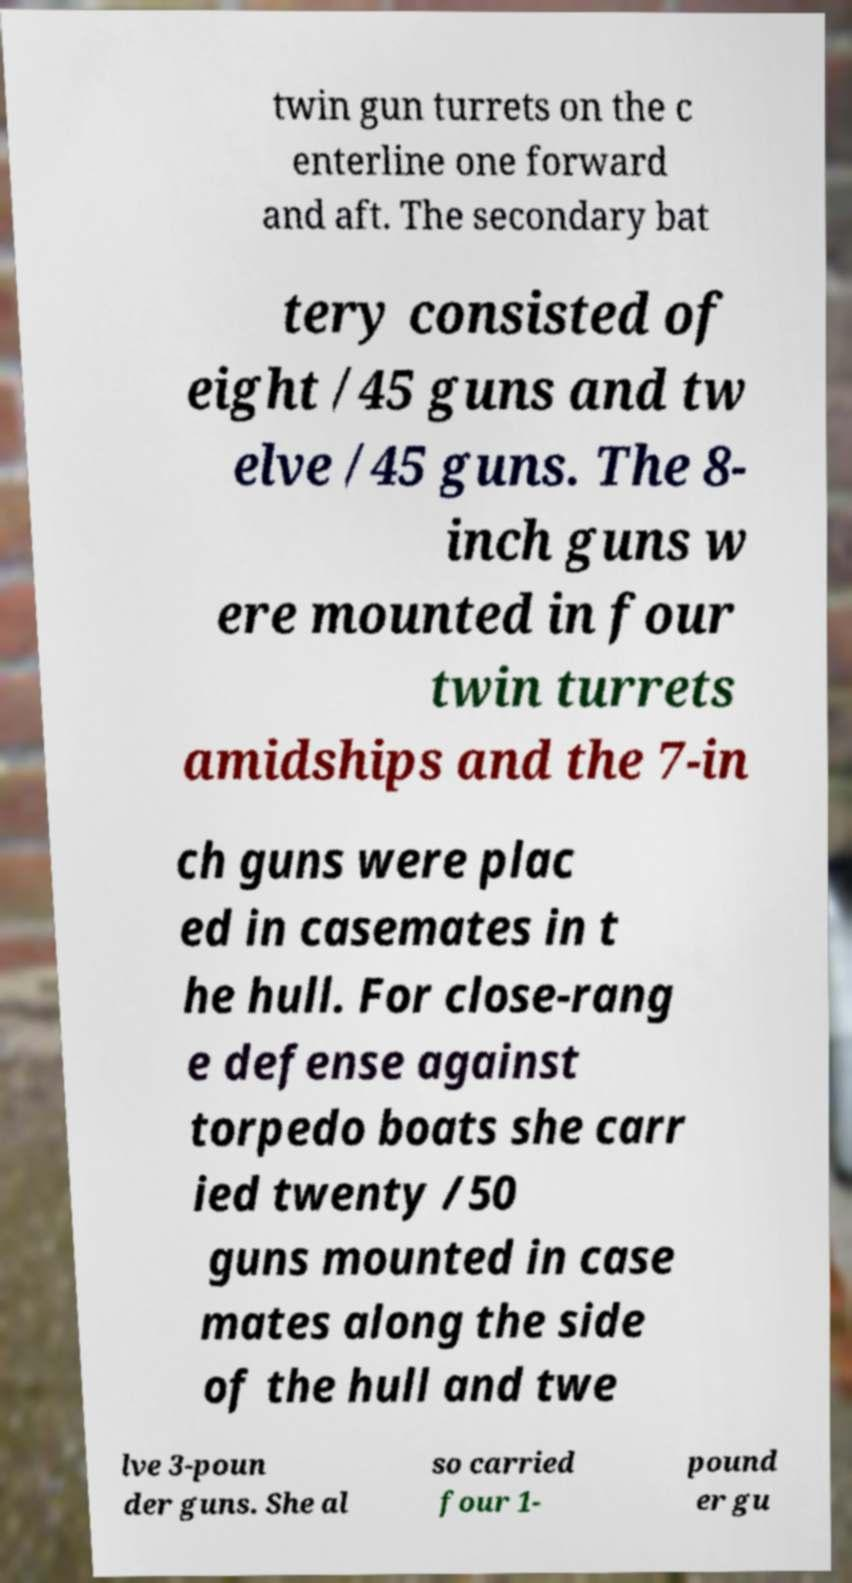For documentation purposes, I need the text within this image transcribed. Could you provide that? twin gun turrets on the c enterline one forward and aft. The secondary bat tery consisted of eight /45 guns and tw elve /45 guns. The 8- inch guns w ere mounted in four twin turrets amidships and the 7-in ch guns were plac ed in casemates in t he hull. For close-rang e defense against torpedo boats she carr ied twenty /50 guns mounted in case mates along the side of the hull and twe lve 3-poun der guns. She al so carried four 1- pound er gu 